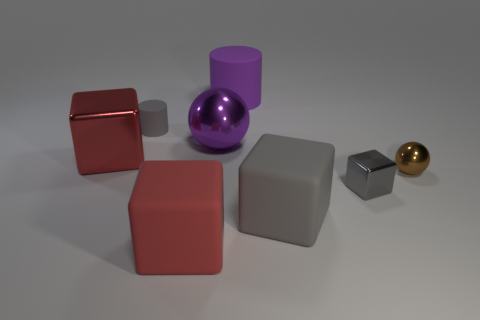Subtract all big blocks. How many blocks are left? 1 Subtract all gray cylinders. How many cylinders are left? 1 Add 1 red things. How many objects exist? 9 Subtract all cylinders. How many objects are left? 6 Subtract 2 cubes. How many cubes are left? 2 Subtract all big purple objects. Subtract all small cyan metallic objects. How many objects are left? 6 Add 1 tiny matte objects. How many tiny matte objects are left? 2 Add 1 cubes. How many cubes exist? 5 Subtract 0 blue cylinders. How many objects are left? 8 Subtract all blue balls. Subtract all purple blocks. How many balls are left? 2 